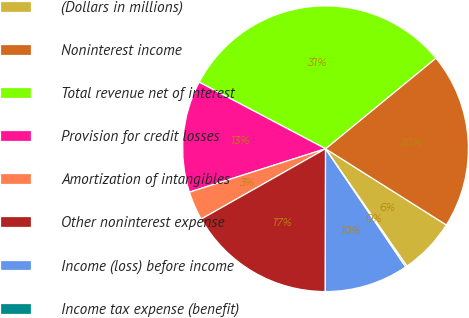Convert chart. <chart><loc_0><loc_0><loc_500><loc_500><pie_chart><fcel>(Dollars in millions)<fcel>Noninterest income<fcel>Total revenue net of interest<fcel>Provision for credit losses<fcel>Amortization of intangibles<fcel>Other noninterest expense<fcel>Income (loss) before income<fcel>Income tax expense (benefit)<nl><fcel>6.4%<fcel>19.9%<fcel>31.34%<fcel>12.63%<fcel>3.28%<fcel>16.78%<fcel>9.51%<fcel>0.16%<nl></chart> 